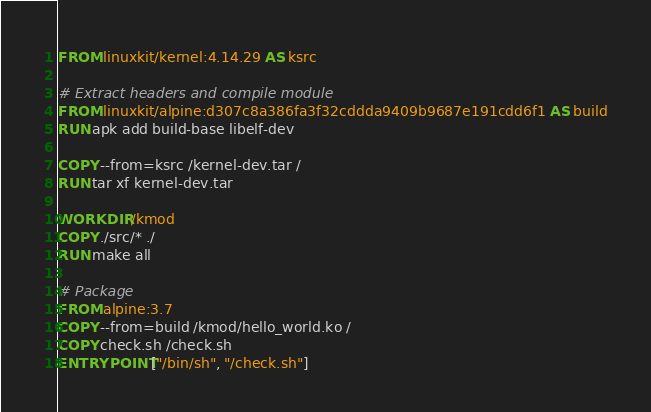<code> <loc_0><loc_0><loc_500><loc_500><_Dockerfile_>
FROM linuxkit/kernel:4.14.29 AS ksrc

# Extract headers and compile module
FROM linuxkit/alpine:d307c8a386fa3f32cddda9409b9687e191cdd6f1 AS build
RUN apk add build-base libelf-dev

COPY --from=ksrc /kernel-dev.tar /
RUN tar xf kernel-dev.tar

WORKDIR /kmod
COPY ./src/* ./
RUN make all

# Package
FROM alpine:3.7
COPY --from=build /kmod/hello_world.ko /
COPY check.sh /check.sh
ENTRYPOINT ["/bin/sh", "/check.sh"]
</code> 